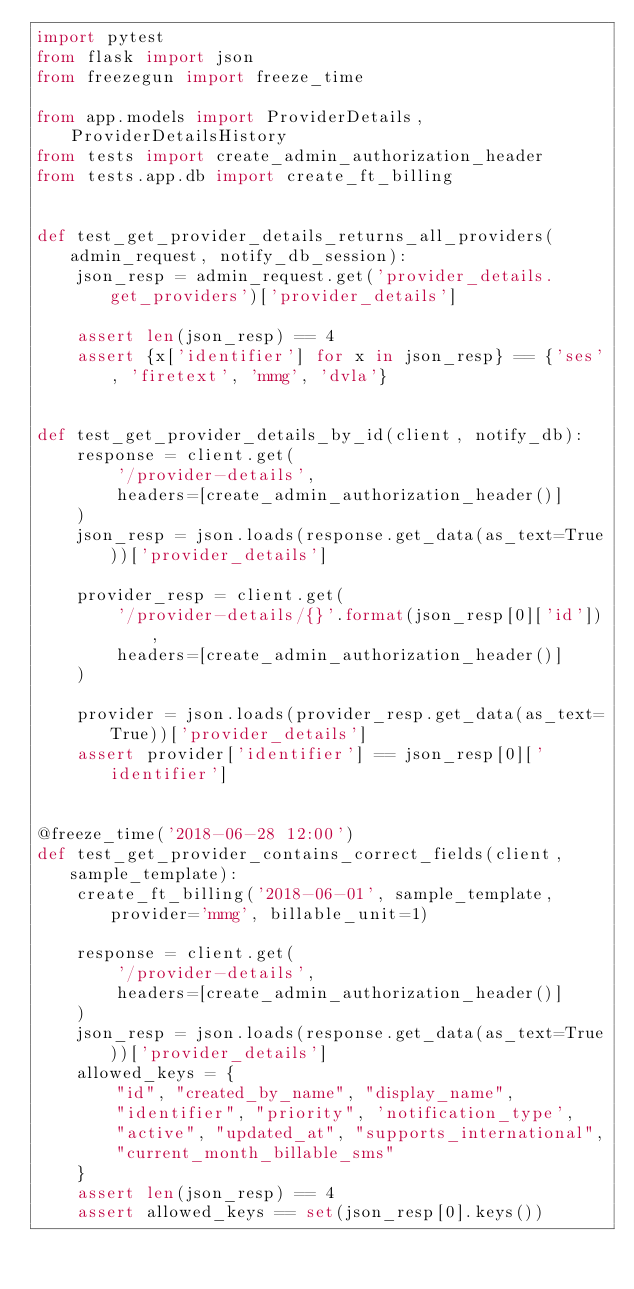Convert code to text. <code><loc_0><loc_0><loc_500><loc_500><_Python_>import pytest
from flask import json
from freezegun import freeze_time

from app.models import ProviderDetails, ProviderDetailsHistory
from tests import create_admin_authorization_header
from tests.app.db import create_ft_billing


def test_get_provider_details_returns_all_providers(admin_request, notify_db_session):
    json_resp = admin_request.get('provider_details.get_providers')['provider_details']

    assert len(json_resp) == 4
    assert {x['identifier'] for x in json_resp} == {'ses', 'firetext', 'mmg', 'dvla'}


def test_get_provider_details_by_id(client, notify_db):
    response = client.get(
        '/provider-details',
        headers=[create_admin_authorization_header()]
    )
    json_resp = json.loads(response.get_data(as_text=True))['provider_details']

    provider_resp = client.get(
        '/provider-details/{}'.format(json_resp[0]['id']),
        headers=[create_admin_authorization_header()]
    )

    provider = json.loads(provider_resp.get_data(as_text=True))['provider_details']
    assert provider['identifier'] == json_resp[0]['identifier']


@freeze_time('2018-06-28 12:00')
def test_get_provider_contains_correct_fields(client, sample_template):
    create_ft_billing('2018-06-01', sample_template, provider='mmg', billable_unit=1)

    response = client.get(
        '/provider-details',
        headers=[create_admin_authorization_header()]
    )
    json_resp = json.loads(response.get_data(as_text=True))['provider_details']
    allowed_keys = {
        "id", "created_by_name", "display_name",
        "identifier", "priority", 'notification_type',
        "active", "updated_at", "supports_international",
        "current_month_billable_sms"
    }
    assert len(json_resp) == 4
    assert allowed_keys == set(json_resp[0].keys())

</code> 